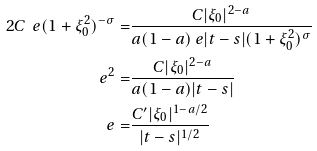<formula> <loc_0><loc_0><loc_500><loc_500>2 C \ e ( 1 + \xi _ { 0 } ^ { 2 } ) ^ { - \sigma } = & \frac { C | \xi _ { 0 } | ^ { 2 - a } } { a ( 1 - a ) \ e | t - s | ( 1 + \xi _ { 0 } ^ { 2 } ) ^ { \sigma } } \\ \ e ^ { 2 } = & \frac { C | \xi _ { 0 } | ^ { 2 - a } } { a ( 1 - a ) | t - s | } \\ \ e = & \frac { C ^ { \prime } | \xi _ { 0 } | ^ { 1 - a / 2 } } { | t - s | ^ { 1 / 2 } }</formula> 